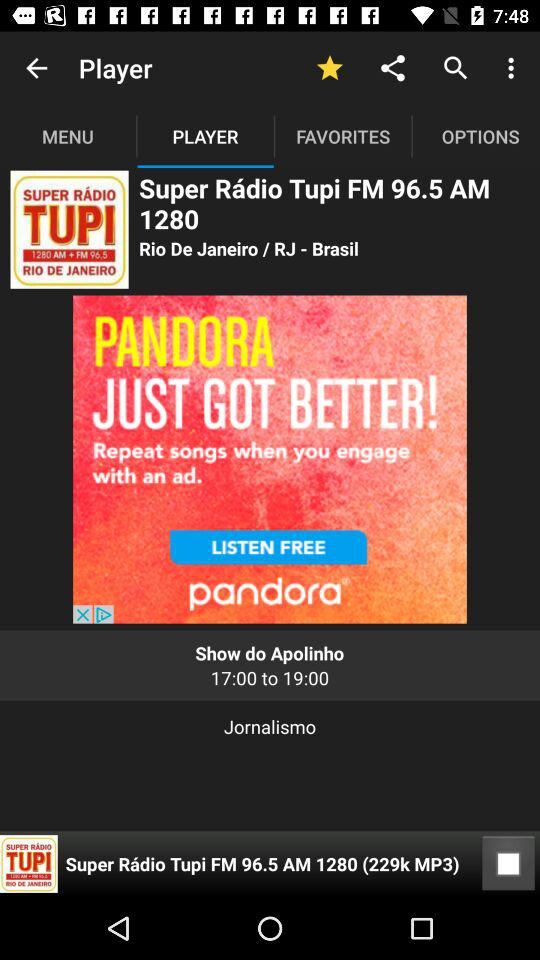What is the name of the radio song in the player?
When the provided information is insufficient, respond with <no answer>. <no answer> 